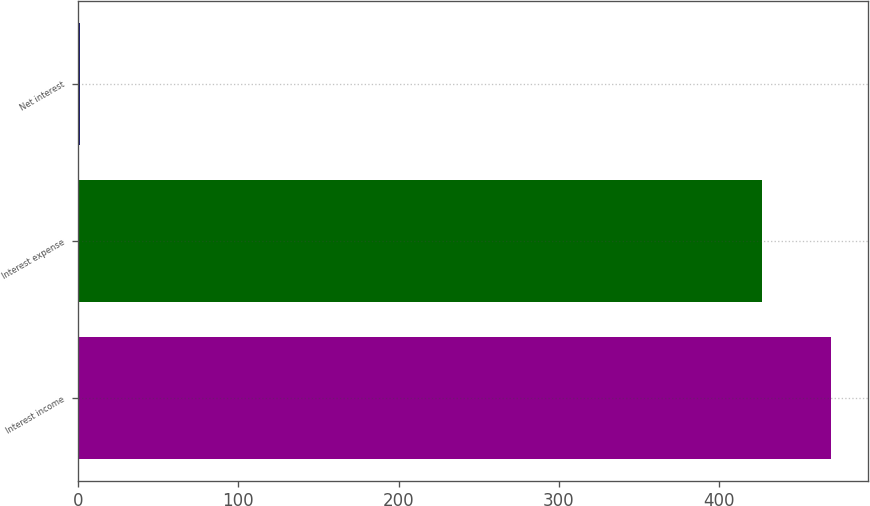Convert chart to OTSL. <chart><loc_0><loc_0><loc_500><loc_500><bar_chart><fcel>Interest income<fcel>Interest expense<fcel>Net interest<nl><fcel>469.7<fcel>427<fcel>1<nl></chart> 